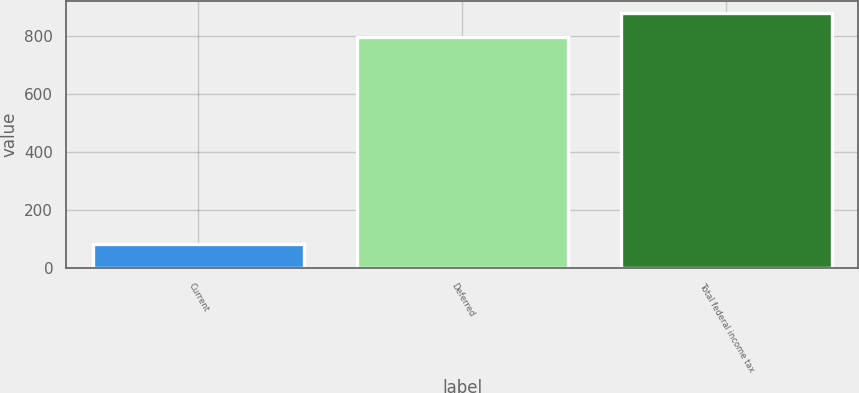Convert chart. <chart><loc_0><loc_0><loc_500><loc_500><bar_chart><fcel>Current<fcel>Deferred<fcel>Total federal income tax<nl><fcel>81<fcel>796<fcel>877<nl></chart> 